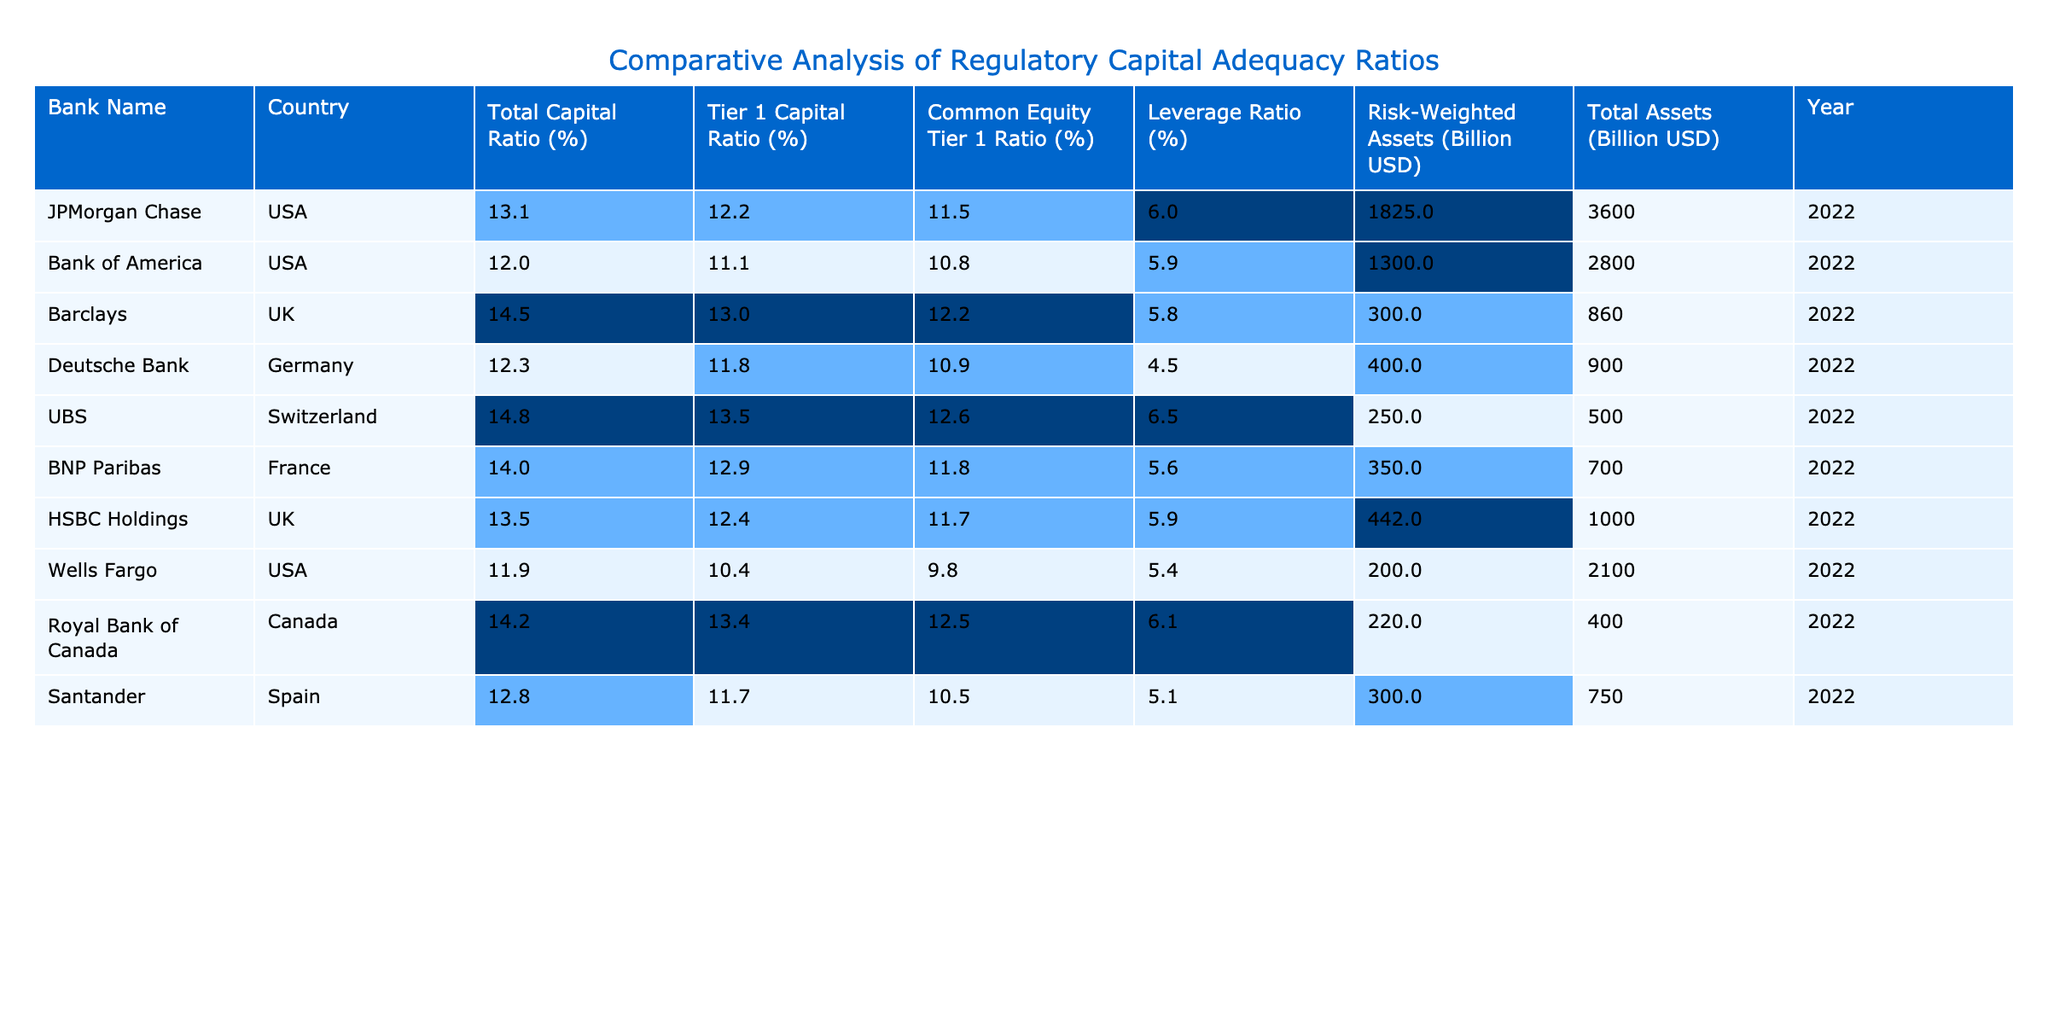What is the Total Capital Ratio of Barclays? The Total Capital Ratio for Barclays is displayed directly in the table as 14.5%.
Answer: 14.5% Which bank has the highest Tier 1 Capital Ratio? By comparing the Tier 1 Capital Ratio values in the table, UBS has the highest value at 13.5%.
Answer: UBS What is the difference between the Total Capital Ratio of JPMorgan Chase and Wells Fargo? The Total Capital Ratio for JPMorgan Chase is 13.1% and for Wells Fargo is 11.9%. The difference is calculated as 13.1% - 11.9% = 1.2%.
Answer: 1.2% Which country has the bank with the lowest Common Equity Tier 1 Ratio? Looking at the Common Equity Tier 1 Ratio values, Wells Fargo has the lowest at 9.8%, and it is based in the USA.
Answer: USA What is the average Total Capital Ratio of the banks listed in the table? The Total Capital Ratios are: 13.1, 12.0, 14.5, 12.3, 14.8, 14.0, 13.5, 11.9, 14.2, and 12.8. Summing these values gives  13.3%, and dividing by 10 (the number of banks) gives an average of 13.3%.
Answer: 13.3% Is the Leverage Ratio for Deutsche Bank greater than 5%? The Leverage Ratio for Deutsche Bank is 4.5%, which is less than 5%, therefore the statement is false.
Answer: No What percentage of banks listed have a Total Capital Ratio above 13%? The banks with Total Capital Ratios above 13% are: JPMorgan Chase, Barclays, UBS, BNP Paribas, HSBC Holdings, and Royal Bank of Canada (6 banks total). There are 10 banks in total, or 60% of them.
Answer: 60% Which bank has the highest Risk-Weighted Assets, and what is that amount? The Risk-Weighted Assets for JPMorgan Chase is 1825 Billion USD, which is the highest among the banks listed.
Answer: JPMorgan Chase, 1825 Billion USD Are there more banks from the USA or Europe in the table? The banks listed from the USA are JPMorgan Chase, Bank of America, Wells Fargo (3 banks). The banks from Europe are Barclays (UK), Deutsche Bank (Germany), UBS (Switzerland), BNP Paribas (France), and HSBC Holdings (UK) (5 banks total). Thus, there are more banks from Europe.
Answer: Europe What is the ratio of Risk-Weighted Assets to Total Assets for Santander? For Santander, Risk-Weighted Assets are 300 Billion USD and Total Assets are 750 Billion USD. The ratio is calculated as 300/750 = 0.4, or 40%.
Answer: 40% 